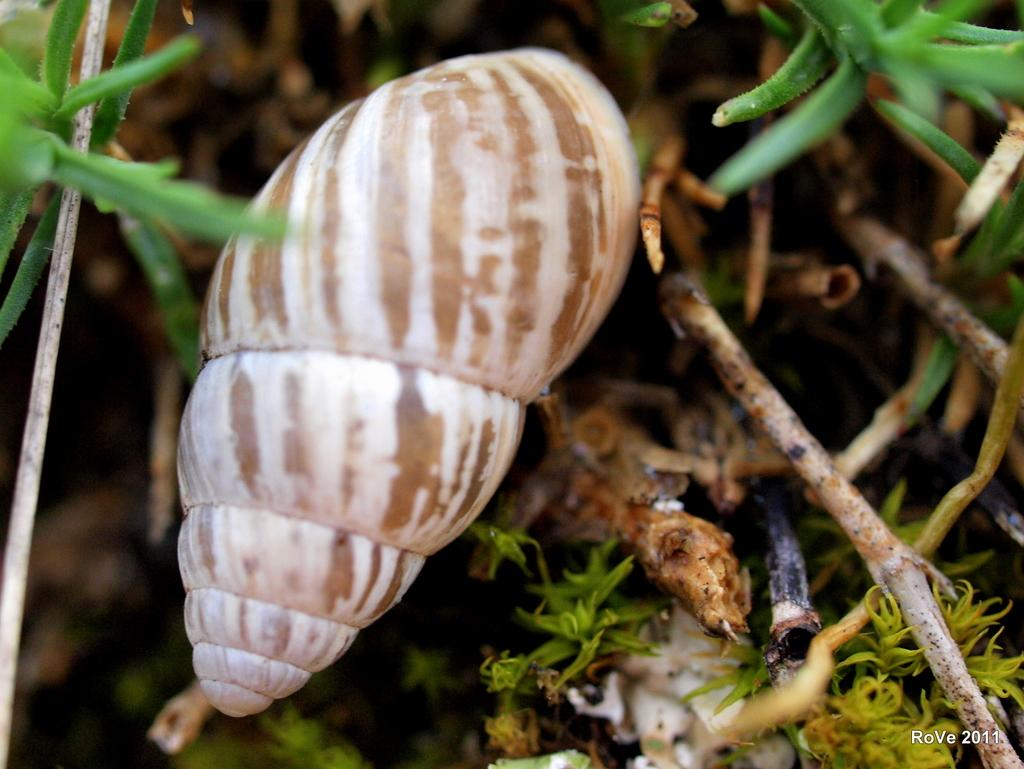What is the main object in the image? There is a seashell in the image. What other elements can be seen in the image? There are plants in the image. What type of pest can be seen crawling on the seashell in the image? There is no pest visible on the seashell in the image. What verse or quote is written on the seashell in the image? There is no verse or quote written on the seashell in the image. 